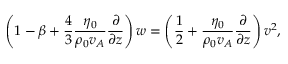Convert formula to latex. <formula><loc_0><loc_0><loc_500><loc_500>\left ( 1 - \beta + \frac { 4 } { 3 } \frac { \eta _ { 0 } } { \rho _ { 0 } v _ { A } } \frac { \partial } { \partial z } \right ) w = \left ( \frac { 1 } { 2 } + \frac { \eta _ { 0 } } { \rho _ { 0 } v _ { A } } \frac { \partial } { \partial z } \right ) v ^ { 2 } ,</formula> 